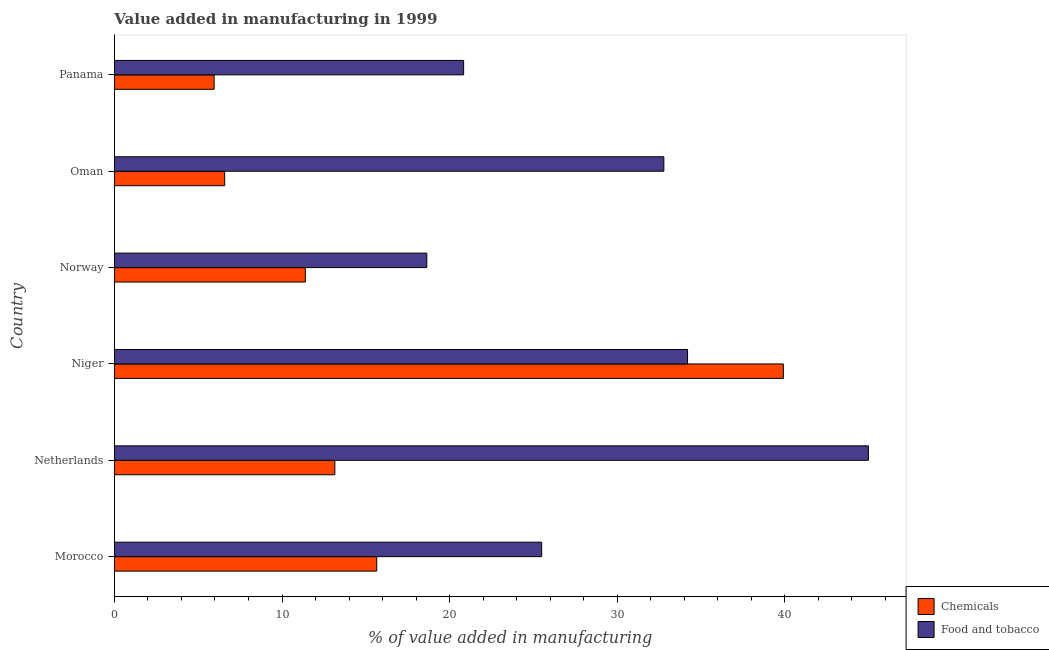How many different coloured bars are there?
Your response must be concise. 2. What is the label of the 6th group of bars from the top?
Ensure brevity in your answer.  Morocco. In how many cases, is the number of bars for a given country not equal to the number of legend labels?
Your answer should be very brief. 0. What is the value added by  manufacturing chemicals in Morocco?
Make the answer very short. 15.65. Across all countries, what is the maximum value added by manufacturing food and tobacco?
Keep it short and to the point. 44.98. Across all countries, what is the minimum value added by manufacturing food and tobacco?
Keep it short and to the point. 18.64. In which country was the value added by  manufacturing chemicals maximum?
Give a very brief answer. Niger. In which country was the value added by manufacturing food and tobacco minimum?
Your answer should be very brief. Norway. What is the total value added by  manufacturing chemicals in the graph?
Your response must be concise. 92.63. What is the difference between the value added by manufacturing food and tobacco in Niger and that in Norway?
Offer a terse response. 15.55. What is the difference between the value added by  manufacturing chemicals in Norway and the value added by manufacturing food and tobacco in Niger?
Provide a succinct answer. -22.8. What is the average value added by  manufacturing chemicals per country?
Provide a succinct answer. 15.44. What is the difference between the value added by manufacturing food and tobacco and value added by  manufacturing chemicals in Niger?
Make the answer very short. -5.72. What is the ratio of the value added by  manufacturing chemicals in Norway to that in Panama?
Provide a succinct answer. 1.92. Is the value added by  manufacturing chemicals in Morocco less than that in Niger?
Give a very brief answer. Yes. What is the difference between the highest and the second highest value added by manufacturing food and tobacco?
Your answer should be compact. 10.79. What is the difference between the highest and the lowest value added by  manufacturing chemicals?
Offer a terse response. 33.96. In how many countries, is the value added by  manufacturing chemicals greater than the average value added by  manufacturing chemicals taken over all countries?
Your answer should be very brief. 2. Is the sum of the value added by  manufacturing chemicals in Norway and Panama greater than the maximum value added by manufacturing food and tobacco across all countries?
Make the answer very short. No. What does the 1st bar from the top in Oman represents?
Your answer should be compact. Food and tobacco. What does the 1st bar from the bottom in Niger represents?
Offer a very short reply. Chemicals. How many bars are there?
Offer a very short reply. 12. Are all the bars in the graph horizontal?
Provide a succinct answer. Yes. What is the difference between two consecutive major ticks on the X-axis?
Offer a very short reply. 10. Are the values on the major ticks of X-axis written in scientific E-notation?
Provide a short and direct response. No. Does the graph contain grids?
Offer a terse response. No. How many legend labels are there?
Provide a short and direct response. 2. How are the legend labels stacked?
Offer a terse response. Vertical. What is the title of the graph?
Your response must be concise. Value added in manufacturing in 1999. What is the label or title of the X-axis?
Your answer should be very brief. % of value added in manufacturing. What is the % of value added in manufacturing in Chemicals in Morocco?
Your response must be concise. 15.65. What is the % of value added in manufacturing of Food and tobacco in Morocco?
Offer a terse response. 25.49. What is the % of value added in manufacturing of Chemicals in Netherlands?
Your answer should be very brief. 13.15. What is the % of value added in manufacturing of Food and tobacco in Netherlands?
Your answer should be compact. 44.98. What is the % of value added in manufacturing of Chemicals in Niger?
Provide a succinct answer. 39.91. What is the % of value added in manufacturing of Food and tobacco in Niger?
Provide a succinct answer. 34.19. What is the % of value added in manufacturing in Chemicals in Norway?
Offer a terse response. 11.39. What is the % of value added in manufacturing in Food and tobacco in Norway?
Your response must be concise. 18.64. What is the % of value added in manufacturing in Chemicals in Oman?
Make the answer very short. 6.58. What is the % of value added in manufacturing of Food and tobacco in Oman?
Offer a very short reply. 32.78. What is the % of value added in manufacturing of Chemicals in Panama?
Ensure brevity in your answer.  5.95. What is the % of value added in manufacturing in Food and tobacco in Panama?
Keep it short and to the point. 20.83. Across all countries, what is the maximum % of value added in manufacturing of Chemicals?
Make the answer very short. 39.91. Across all countries, what is the maximum % of value added in manufacturing in Food and tobacco?
Offer a terse response. 44.98. Across all countries, what is the minimum % of value added in manufacturing of Chemicals?
Your answer should be very brief. 5.95. Across all countries, what is the minimum % of value added in manufacturing of Food and tobacco?
Give a very brief answer. 18.64. What is the total % of value added in manufacturing in Chemicals in the graph?
Ensure brevity in your answer.  92.63. What is the total % of value added in manufacturing in Food and tobacco in the graph?
Your answer should be compact. 176.92. What is the difference between the % of value added in manufacturing in Chemicals in Morocco and that in Netherlands?
Your answer should be compact. 2.5. What is the difference between the % of value added in manufacturing of Food and tobacco in Morocco and that in Netherlands?
Give a very brief answer. -19.49. What is the difference between the % of value added in manufacturing of Chemicals in Morocco and that in Niger?
Make the answer very short. -24.26. What is the difference between the % of value added in manufacturing of Food and tobacco in Morocco and that in Niger?
Your answer should be compact. -8.7. What is the difference between the % of value added in manufacturing of Chemicals in Morocco and that in Norway?
Make the answer very short. 4.26. What is the difference between the % of value added in manufacturing in Food and tobacco in Morocco and that in Norway?
Give a very brief answer. 6.85. What is the difference between the % of value added in manufacturing in Chemicals in Morocco and that in Oman?
Offer a terse response. 9.07. What is the difference between the % of value added in manufacturing of Food and tobacco in Morocco and that in Oman?
Give a very brief answer. -7.29. What is the difference between the % of value added in manufacturing of Chemicals in Morocco and that in Panama?
Keep it short and to the point. 9.7. What is the difference between the % of value added in manufacturing of Food and tobacco in Morocco and that in Panama?
Ensure brevity in your answer.  4.66. What is the difference between the % of value added in manufacturing in Chemicals in Netherlands and that in Niger?
Ensure brevity in your answer.  -26.76. What is the difference between the % of value added in manufacturing of Food and tobacco in Netherlands and that in Niger?
Keep it short and to the point. 10.79. What is the difference between the % of value added in manufacturing in Chemicals in Netherlands and that in Norway?
Provide a succinct answer. 1.76. What is the difference between the % of value added in manufacturing in Food and tobacco in Netherlands and that in Norway?
Provide a short and direct response. 26.34. What is the difference between the % of value added in manufacturing in Chemicals in Netherlands and that in Oman?
Your answer should be very brief. 6.57. What is the difference between the % of value added in manufacturing in Food and tobacco in Netherlands and that in Oman?
Give a very brief answer. 12.2. What is the difference between the % of value added in manufacturing in Chemicals in Netherlands and that in Panama?
Your answer should be very brief. 7.2. What is the difference between the % of value added in manufacturing in Food and tobacco in Netherlands and that in Panama?
Your response must be concise. 24.15. What is the difference between the % of value added in manufacturing in Chemicals in Niger and that in Norway?
Give a very brief answer. 28.52. What is the difference between the % of value added in manufacturing of Food and tobacco in Niger and that in Norway?
Offer a very short reply. 15.56. What is the difference between the % of value added in manufacturing in Chemicals in Niger and that in Oman?
Give a very brief answer. 33.33. What is the difference between the % of value added in manufacturing in Food and tobacco in Niger and that in Oman?
Offer a very short reply. 1.41. What is the difference between the % of value added in manufacturing of Chemicals in Niger and that in Panama?
Provide a short and direct response. 33.96. What is the difference between the % of value added in manufacturing of Food and tobacco in Niger and that in Panama?
Offer a terse response. 13.36. What is the difference between the % of value added in manufacturing of Chemicals in Norway and that in Oman?
Offer a terse response. 4.81. What is the difference between the % of value added in manufacturing of Food and tobacco in Norway and that in Oman?
Provide a succinct answer. -14.14. What is the difference between the % of value added in manufacturing of Chemicals in Norway and that in Panama?
Give a very brief answer. 5.44. What is the difference between the % of value added in manufacturing of Food and tobacco in Norway and that in Panama?
Your answer should be very brief. -2.2. What is the difference between the % of value added in manufacturing in Chemicals in Oman and that in Panama?
Your answer should be very brief. 0.63. What is the difference between the % of value added in manufacturing of Food and tobacco in Oman and that in Panama?
Make the answer very short. 11.95. What is the difference between the % of value added in manufacturing in Chemicals in Morocco and the % of value added in manufacturing in Food and tobacco in Netherlands?
Provide a short and direct response. -29.33. What is the difference between the % of value added in manufacturing in Chemicals in Morocco and the % of value added in manufacturing in Food and tobacco in Niger?
Ensure brevity in your answer.  -18.54. What is the difference between the % of value added in manufacturing in Chemicals in Morocco and the % of value added in manufacturing in Food and tobacco in Norway?
Provide a short and direct response. -2.99. What is the difference between the % of value added in manufacturing in Chemicals in Morocco and the % of value added in manufacturing in Food and tobacco in Oman?
Ensure brevity in your answer.  -17.13. What is the difference between the % of value added in manufacturing of Chemicals in Morocco and the % of value added in manufacturing of Food and tobacco in Panama?
Provide a succinct answer. -5.18. What is the difference between the % of value added in manufacturing in Chemicals in Netherlands and the % of value added in manufacturing in Food and tobacco in Niger?
Your answer should be compact. -21.04. What is the difference between the % of value added in manufacturing in Chemicals in Netherlands and the % of value added in manufacturing in Food and tobacco in Norway?
Your answer should be compact. -5.49. What is the difference between the % of value added in manufacturing of Chemicals in Netherlands and the % of value added in manufacturing of Food and tobacco in Oman?
Your answer should be very brief. -19.63. What is the difference between the % of value added in manufacturing of Chemicals in Netherlands and the % of value added in manufacturing of Food and tobacco in Panama?
Give a very brief answer. -7.68. What is the difference between the % of value added in manufacturing of Chemicals in Niger and the % of value added in manufacturing of Food and tobacco in Norway?
Your answer should be very brief. 21.27. What is the difference between the % of value added in manufacturing in Chemicals in Niger and the % of value added in manufacturing in Food and tobacco in Oman?
Provide a short and direct response. 7.13. What is the difference between the % of value added in manufacturing in Chemicals in Niger and the % of value added in manufacturing in Food and tobacco in Panama?
Offer a terse response. 19.08. What is the difference between the % of value added in manufacturing of Chemicals in Norway and the % of value added in manufacturing of Food and tobacco in Oman?
Offer a terse response. -21.39. What is the difference between the % of value added in manufacturing of Chemicals in Norway and the % of value added in manufacturing of Food and tobacco in Panama?
Ensure brevity in your answer.  -9.44. What is the difference between the % of value added in manufacturing in Chemicals in Oman and the % of value added in manufacturing in Food and tobacco in Panama?
Keep it short and to the point. -14.26. What is the average % of value added in manufacturing of Chemicals per country?
Offer a terse response. 15.44. What is the average % of value added in manufacturing in Food and tobacco per country?
Offer a terse response. 29.49. What is the difference between the % of value added in manufacturing of Chemicals and % of value added in manufacturing of Food and tobacco in Morocco?
Your response must be concise. -9.84. What is the difference between the % of value added in manufacturing in Chemicals and % of value added in manufacturing in Food and tobacco in Netherlands?
Ensure brevity in your answer.  -31.83. What is the difference between the % of value added in manufacturing in Chemicals and % of value added in manufacturing in Food and tobacco in Niger?
Your response must be concise. 5.72. What is the difference between the % of value added in manufacturing in Chemicals and % of value added in manufacturing in Food and tobacco in Norway?
Make the answer very short. -7.25. What is the difference between the % of value added in manufacturing of Chemicals and % of value added in manufacturing of Food and tobacco in Oman?
Provide a succinct answer. -26.2. What is the difference between the % of value added in manufacturing in Chemicals and % of value added in manufacturing in Food and tobacco in Panama?
Your response must be concise. -14.89. What is the ratio of the % of value added in manufacturing of Chemicals in Morocco to that in Netherlands?
Provide a succinct answer. 1.19. What is the ratio of the % of value added in manufacturing of Food and tobacco in Morocco to that in Netherlands?
Give a very brief answer. 0.57. What is the ratio of the % of value added in manufacturing in Chemicals in Morocco to that in Niger?
Offer a very short reply. 0.39. What is the ratio of the % of value added in manufacturing in Food and tobacco in Morocco to that in Niger?
Ensure brevity in your answer.  0.75. What is the ratio of the % of value added in manufacturing in Chemicals in Morocco to that in Norway?
Your answer should be compact. 1.37. What is the ratio of the % of value added in manufacturing in Food and tobacco in Morocco to that in Norway?
Keep it short and to the point. 1.37. What is the ratio of the % of value added in manufacturing of Chemicals in Morocco to that in Oman?
Offer a terse response. 2.38. What is the ratio of the % of value added in manufacturing in Food and tobacco in Morocco to that in Oman?
Give a very brief answer. 0.78. What is the ratio of the % of value added in manufacturing of Chemicals in Morocco to that in Panama?
Provide a succinct answer. 2.63. What is the ratio of the % of value added in manufacturing of Food and tobacco in Morocco to that in Panama?
Your answer should be very brief. 1.22. What is the ratio of the % of value added in manufacturing of Chemicals in Netherlands to that in Niger?
Offer a very short reply. 0.33. What is the ratio of the % of value added in manufacturing in Food and tobacco in Netherlands to that in Niger?
Offer a terse response. 1.32. What is the ratio of the % of value added in manufacturing in Chemicals in Netherlands to that in Norway?
Make the answer very short. 1.15. What is the ratio of the % of value added in manufacturing in Food and tobacco in Netherlands to that in Norway?
Offer a terse response. 2.41. What is the ratio of the % of value added in manufacturing of Chemicals in Netherlands to that in Oman?
Offer a terse response. 2. What is the ratio of the % of value added in manufacturing in Food and tobacco in Netherlands to that in Oman?
Keep it short and to the point. 1.37. What is the ratio of the % of value added in manufacturing in Chemicals in Netherlands to that in Panama?
Your answer should be compact. 2.21. What is the ratio of the % of value added in manufacturing in Food and tobacco in Netherlands to that in Panama?
Provide a short and direct response. 2.16. What is the ratio of the % of value added in manufacturing in Chemicals in Niger to that in Norway?
Offer a terse response. 3.5. What is the ratio of the % of value added in manufacturing in Food and tobacco in Niger to that in Norway?
Provide a succinct answer. 1.83. What is the ratio of the % of value added in manufacturing of Chemicals in Niger to that in Oman?
Your answer should be very brief. 6.07. What is the ratio of the % of value added in manufacturing in Food and tobacco in Niger to that in Oman?
Ensure brevity in your answer.  1.04. What is the ratio of the % of value added in manufacturing of Chemicals in Niger to that in Panama?
Offer a very short reply. 6.71. What is the ratio of the % of value added in manufacturing in Food and tobacco in Niger to that in Panama?
Provide a short and direct response. 1.64. What is the ratio of the % of value added in manufacturing in Chemicals in Norway to that in Oman?
Your answer should be very brief. 1.73. What is the ratio of the % of value added in manufacturing of Food and tobacco in Norway to that in Oman?
Your answer should be compact. 0.57. What is the ratio of the % of value added in manufacturing of Chemicals in Norway to that in Panama?
Ensure brevity in your answer.  1.91. What is the ratio of the % of value added in manufacturing of Food and tobacco in Norway to that in Panama?
Offer a very short reply. 0.89. What is the ratio of the % of value added in manufacturing of Chemicals in Oman to that in Panama?
Offer a very short reply. 1.11. What is the ratio of the % of value added in manufacturing in Food and tobacco in Oman to that in Panama?
Your answer should be very brief. 1.57. What is the difference between the highest and the second highest % of value added in manufacturing of Chemicals?
Provide a short and direct response. 24.26. What is the difference between the highest and the second highest % of value added in manufacturing of Food and tobacco?
Give a very brief answer. 10.79. What is the difference between the highest and the lowest % of value added in manufacturing of Chemicals?
Offer a very short reply. 33.96. What is the difference between the highest and the lowest % of value added in manufacturing in Food and tobacco?
Offer a very short reply. 26.34. 